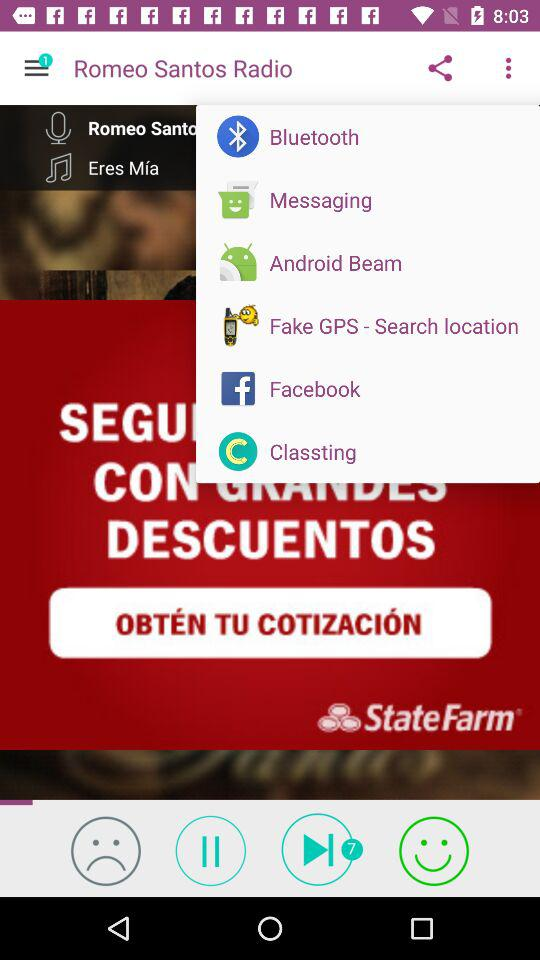What is the singer's name? The singer's name is Romeo Santos. 